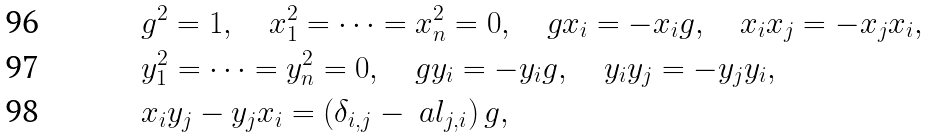Convert formula to latex. <formula><loc_0><loc_0><loc_500><loc_500>& g ^ { 2 } = 1 , \quad x _ { 1 } ^ { 2 } = \dots = x _ { n } ^ { 2 } = 0 , \quad g x _ { i } = - x _ { i } g , \quad x _ { i } x _ { j } = - x _ { j } x _ { i } , \\ & y _ { 1 } ^ { 2 } = \dots = y _ { n } ^ { 2 } = 0 , \quad g y _ { i } = - y _ { i } g , \quad y _ { i } y _ { j } = - y _ { j } y _ { i } , \\ & x _ { i } y _ { j } - y _ { j } x _ { i } = ( \delta _ { i , j } - \ a l _ { j , i } ) \, g ,</formula> 